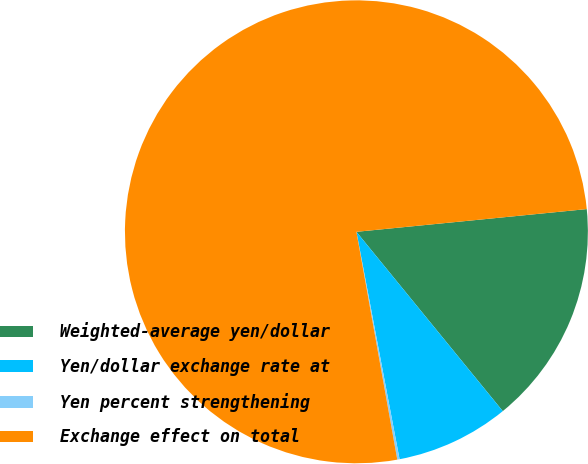Convert chart to OTSL. <chart><loc_0><loc_0><loc_500><loc_500><pie_chart><fcel>Weighted-average yen/dollar<fcel>Yen/dollar exchange rate at<fcel>Yen percent strengthening<fcel>Exchange effect on total<nl><fcel>15.67%<fcel>7.91%<fcel>0.16%<fcel>76.26%<nl></chart> 